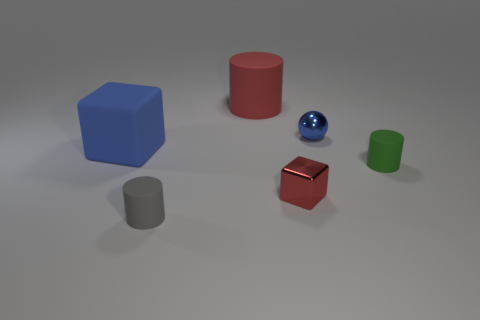Are there any other things that are the same shape as the blue metallic object?
Provide a short and direct response. No. Is the sphere the same size as the blue matte object?
Your answer should be very brief. No. What shape is the thing that is the same color as the tiny shiny cube?
Offer a very short reply. Cylinder. Does the blue metal thing have the same size as the rubber cylinder right of the red shiny object?
Give a very brief answer. Yes. There is a thing that is both left of the big red matte cylinder and right of the matte cube; what is its color?
Ensure brevity in your answer.  Gray. Are there more cylinders that are behind the big cube than small gray rubber cylinders that are in front of the small gray thing?
Your answer should be compact. Yes. There is a green object that is the same material as the small gray thing; what is its size?
Provide a succinct answer. Small. How many small gray matte things are to the left of the rubber cylinder to the left of the big cylinder?
Your response must be concise. 0. Are there any other metal things of the same shape as the tiny blue metallic thing?
Your response must be concise. No. What color is the small rubber cylinder left of the red object behind the metallic ball?
Keep it short and to the point. Gray. 